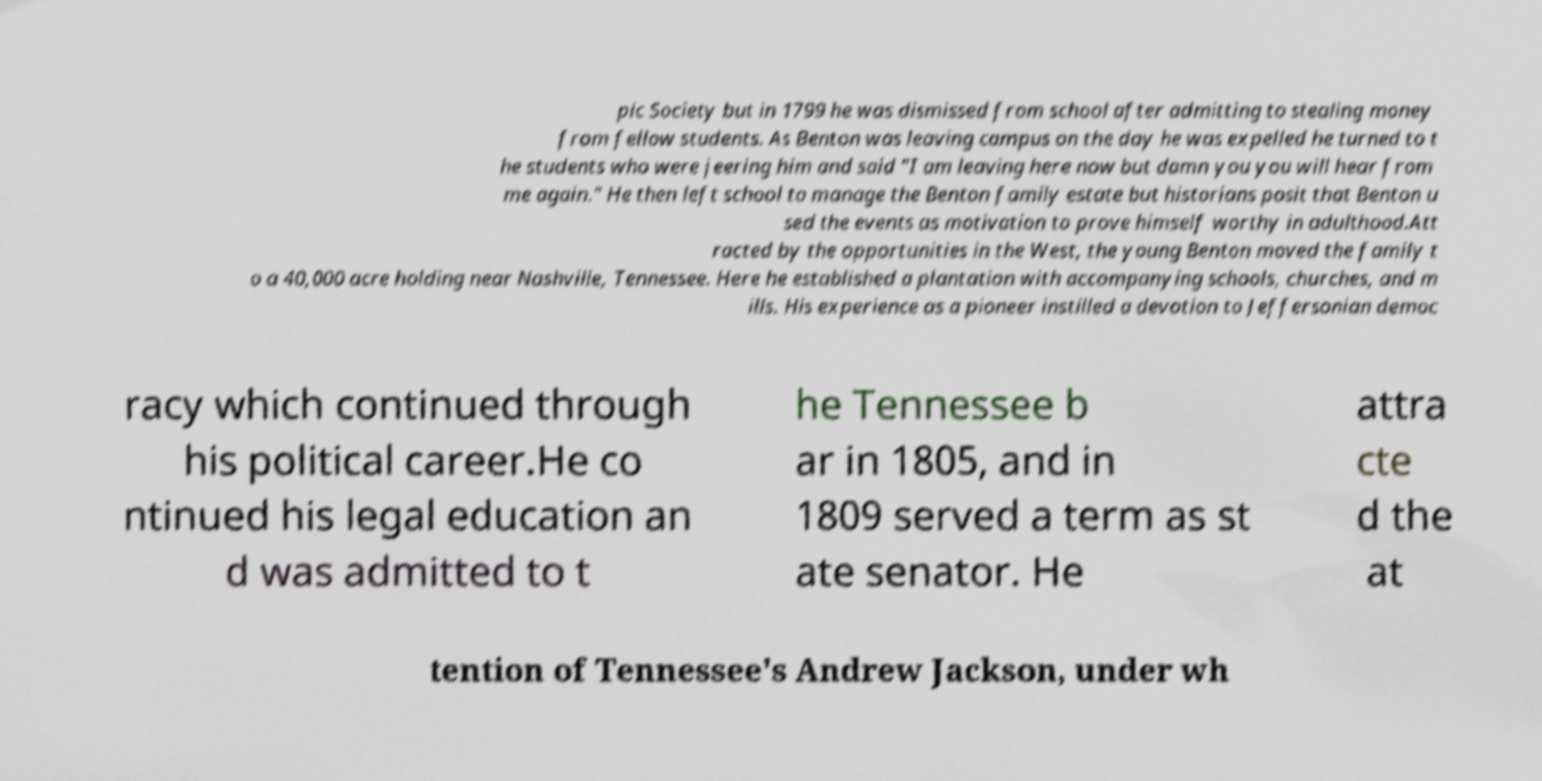Could you extract and type out the text from this image? pic Society but in 1799 he was dismissed from school after admitting to stealing money from fellow students. As Benton was leaving campus on the day he was expelled he turned to t he students who were jeering him and said "I am leaving here now but damn you you will hear from me again." He then left school to manage the Benton family estate but historians posit that Benton u sed the events as motivation to prove himself worthy in adulthood.Att racted by the opportunities in the West, the young Benton moved the family t o a 40,000 acre holding near Nashville, Tennessee. Here he established a plantation with accompanying schools, churches, and m ills. His experience as a pioneer instilled a devotion to Jeffersonian democ racy which continued through his political career.He co ntinued his legal education an d was admitted to t he Tennessee b ar in 1805, and in 1809 served a term as st ate senator. He attra cte d the at tention of Tennessee's Andrew Jackson, under wh 